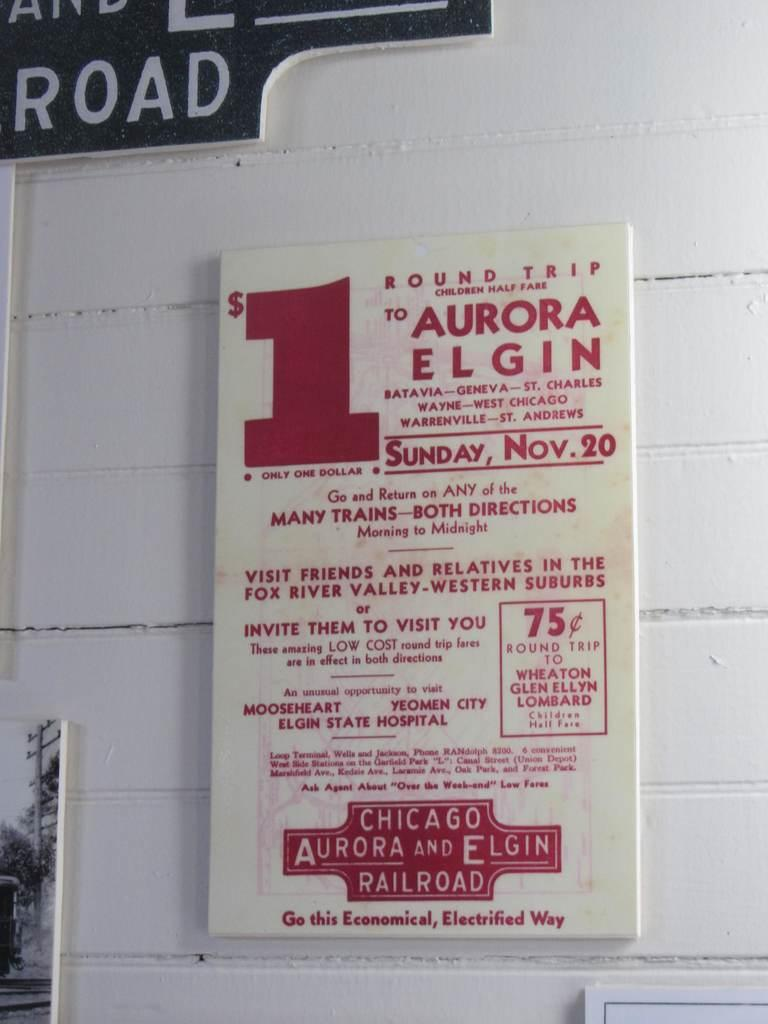<image>
Provide a brief description of the given image. White and red sign on a wall which has the number 1 in red. 